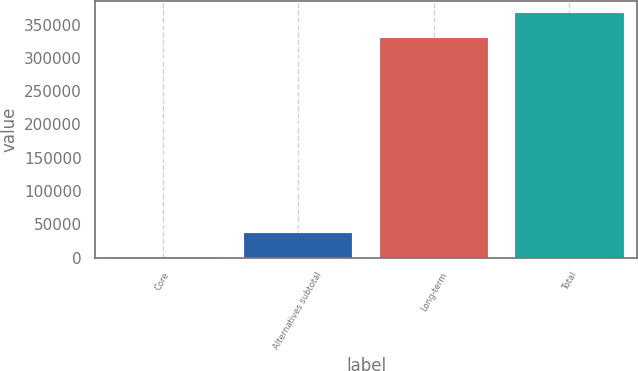<chart> <loc_0><loc_0><loc_500><loc_500><bar_chart><fcel>Core<fcel>Alternatives subtotal<fcel>Long-term<fcel>Total<nl><fcel>780<fcel>37427.4<fcel>330240<fcel>367254<nl></chart> 